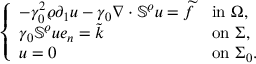Convert formula to latex. <formula><loc_0><loc_0><loc_500><loc_500>\left \{ \begin{array} { l l } { - \gamma _ { 0 } ^ { 2 } \varrho \partial _ { 1 } u - \gamma _ { 0 } \nabla \cdot \mathbb { S } ^ { \varrho } u = \widetilde { f } } & { i n \Omega , } \\ { \gamma _ { 0 } \mathbb { S } ^ { \varrho } u e _ { n } = \widetilde { k } } & { o n \Sigma , } \\ { u = 0 } & { o n \Sigma _ { 0 } . } \end{array}</formula> 